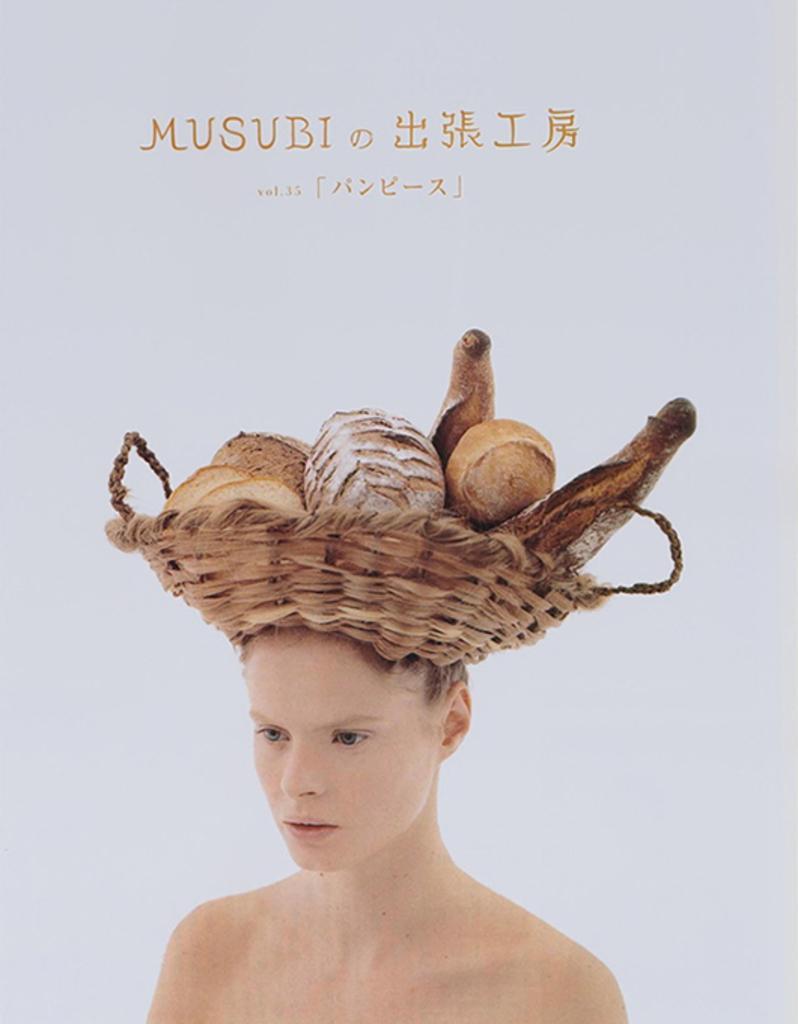In one or two sentences, can you explain what this image depicts? This is a poster and in this poster we can see a basket on a person head with some objects in it and some text. 